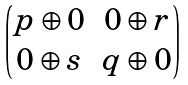<formula> <loc_0><loc_0><loc_500><loc_500>\begin{pmatrix} p \oplus 0 & 0 \oplus r \\ 0 \oplus s & q \oplus 0 \end{pmatrix}</formula> 